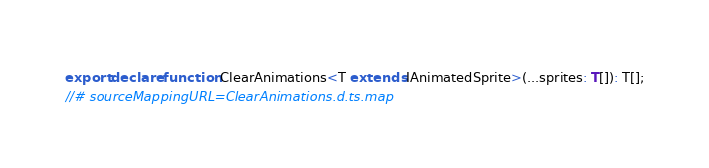Convert code to text. <code><loc_0><loc_0><loc_500><loc_500><_TypeScript_>export declare function ClearAnimations<T extends IAnimatedSprite>(...sprites: T[]): T[];
//# sourceMappingURL=ClearAnimations.d.ts.map</code> 